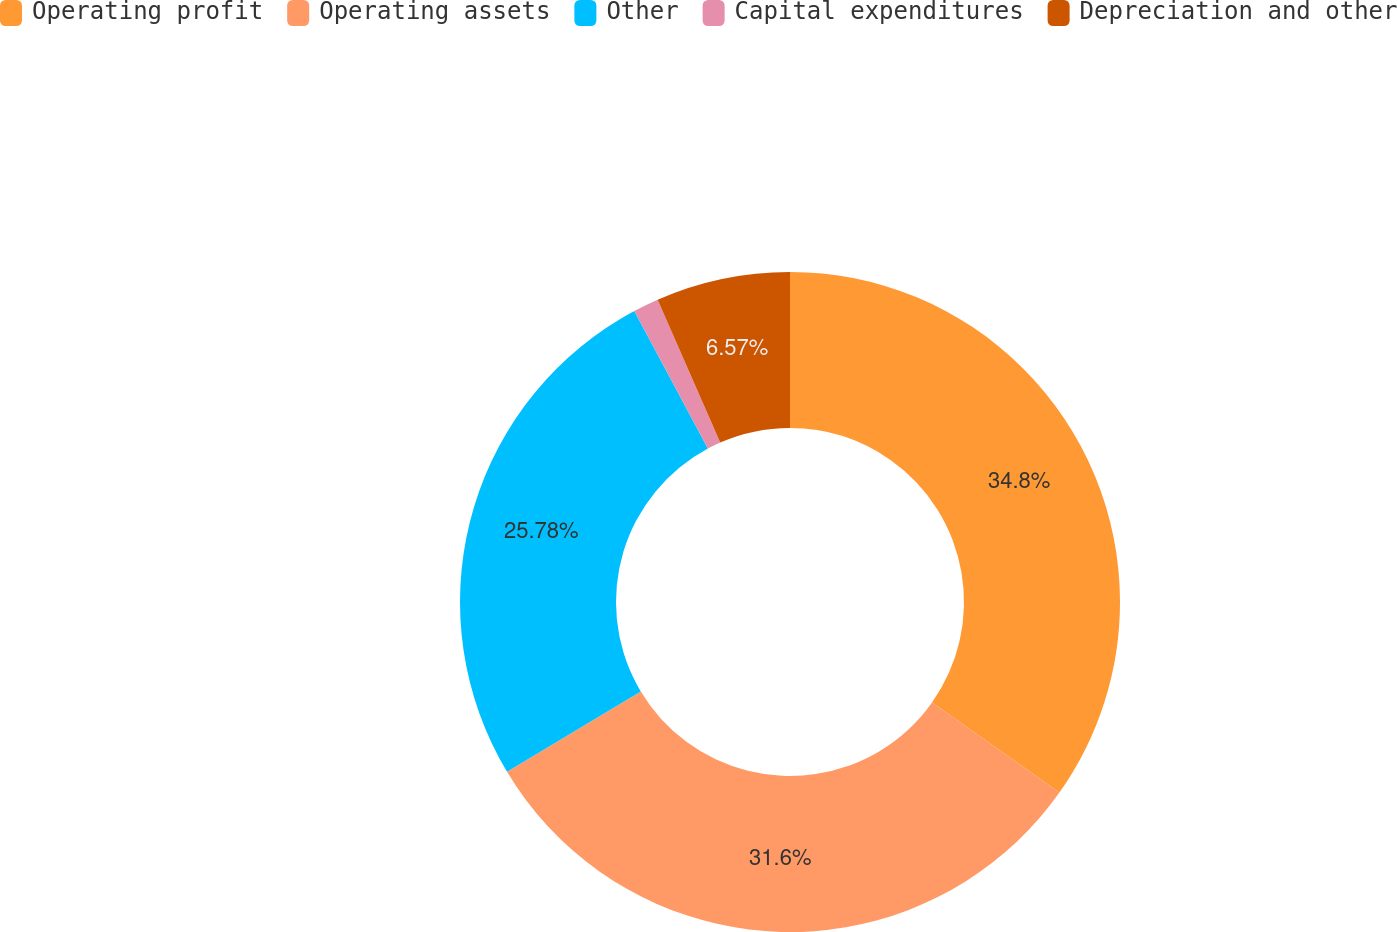Convert chart. <chart><loc_0><loc_0><loc_500><loc_500><pie_chart><fcel>Operating profit<fcel>Operating assets<fcel>Other<fcel>Capital expenditures<fcel>Depreciation and other<nl><fcel>34.8%<fcel>31.6%<fcel>25.78%<fcel>1.25%<fcel>6.57%<nl></chart> 